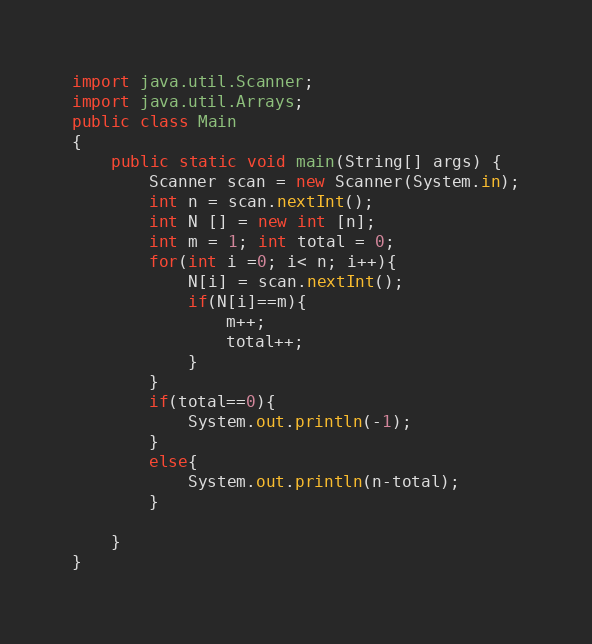<code> <loc_0><loc_0><loc_500><loc_500><_Java_>import java.util.Scanner;
import java.util.Arrays;
public class Main
{
	public static void main(String[] args) {
		Scanner scan = new Scanner(System.in);
		int n = scan.nextInt();
		int N [] = new int [n];
		int m = 1; int total = 0;
		for(int i =0; i< n; i++){
		    N[i] = scan.nextInt();
		    if(N[i]==m){
		        m++;
		        total++;
		    }
		} 
		if(total==0){
		    System.out.println(-1);
		}
		else{
		    System.out.println(n-total);
		}
		
	}
}
</code> 